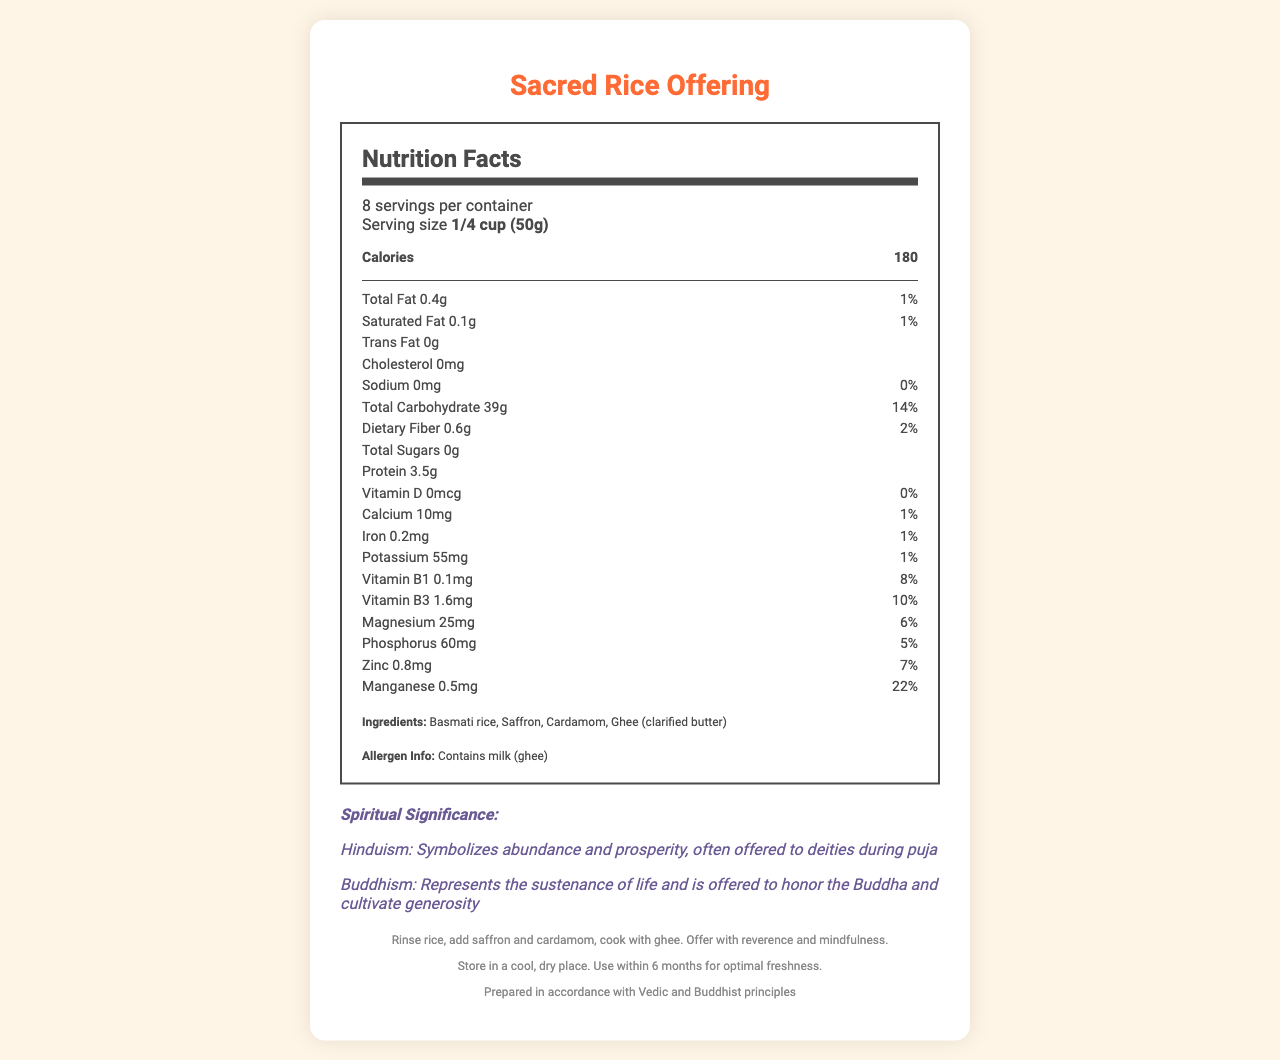what is the serving size of the Sacred Rice Offering? The document lists the serving size as "1/4 cup (50g)" near the top of the nutritional information section.
Answer: 1/4 cup (50g) how many calories are in one serving? The document specifies that each serving contains 180 calories.
Answer: 180 calories how much protein does one serving contain? According to the nutritional facts, there are 3.5g of protein per serving.
Answer: 3.5g how many servings are there per container? The serving information states there are 8 servings per container.
Answer: 8 servings what is the main spiritual significance of this rice offering in Hinduism? The spiritual significance in Hinduism is described as symbolizing abundance and prosperity and is often offered to deities during puja.
Answer: Symbolizes abundance and prosperity, often offered to deities during puja which nutrient has the highest daily value percentage? A. Vitamin B1 B. Manganese C. Iron D. Vitamin D The document shows Manganese has a daily value percentage of 22%, which is the highest among all listed nutrients.
Answer: B. Manganese what ingredient in the Sacred Rice Offering might be of concern for people with dairy allergies? The allergen info section states that the product contains milk (ghee), which is a concern for people with dairy allergies.
Answer: Ghee (clarified butter) how is the Sacred Rice Offering prepared? The preparation instructions specify the rice should be rinsed, then saffron and cardamom added, and cooked with ghee.
Answer: Rinse rice, add saffron and cardamom, cook with ghee what is the cholesterol content per serving? The nutrition facts label indicates that the cholesterol content per serving is 0mg.
Answer: 0mg does the Sacred Rice Offering contain any trans fat? The nutritional information lists 0g of trans fat per serving.
Answer: No what is the total carbohydrate content per serving? It is specified in the nutritional facts that the total carbohydrate content per serving is 39g.
Answer: 39g what is the significance of the rice offering in Buddhism? According to the document, in Buddhism, the rice offering represents the sustenance of life and is offered to honor the Buddha and cultivate generosity.
Answer: Represents the sustenance of life and is offered to honor the Buddha and cultivate generosity what is the daily value percentage of Iron per serving? A. 1% B. 2% C. 8% D. 10% The document specifies that the daily value percentage of Iron per serving is 1%.
Answer: A. 1% how much dietary fiber does one serving contain? According to the nutritional facts, one serving contains 0.6g of dietary fiber.
Answer: 0.6g how much Vitamin D is in one serving? The document notes that there is 0mcg of Vitamin D in one serving.
Answer: 0mcg briefly summarize the main details presented in the document The document details the nutritional information, spiritual significance, ingredients, preparation, and storage instructions for the Sacred Rice Offering. It highlights its role in Hindu and Buddhist rituals and its nutrient content per serving.
Answer: The Sacred Rice Offering is a spiritual food item used in Hindu and Buddhist rituals symbolizing abundance, prosperity, and generosity. It contains 180 calories per serving with 39g of carbohydrates and 3.5g of protein. The ingredient list includes basmati rice, saffron, cardamom, and ghee. The document also provides preparation instructions and storage guidelines. what are the preparation instructions for the Sacred Rice Offering? The preparation instructions are not provided in the expected format within the nutritional facts label itself.
Answer: Cannot be determined what is the daily value percentage of Magnesium per serving? The document specifies that the daily value percentage of Magnesium per serving is 6%.
Answer: 6% 